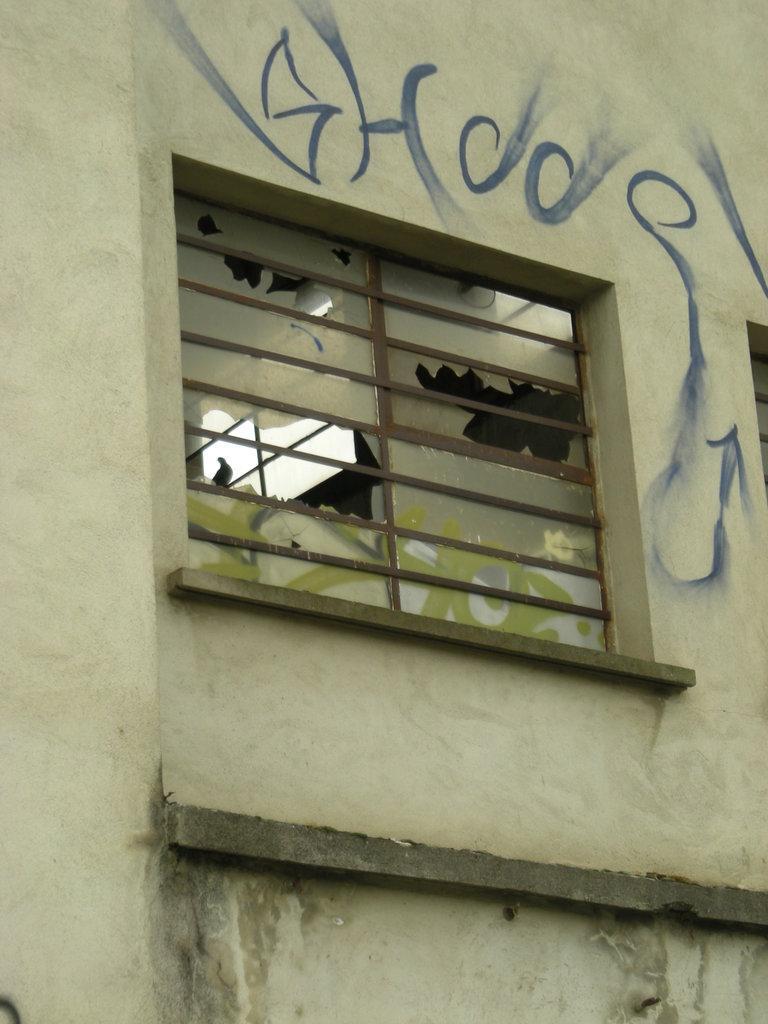How would you summarize this image in a sentence or two? In this image, we can see a wall and there is a window, we can see some text on the wall. 